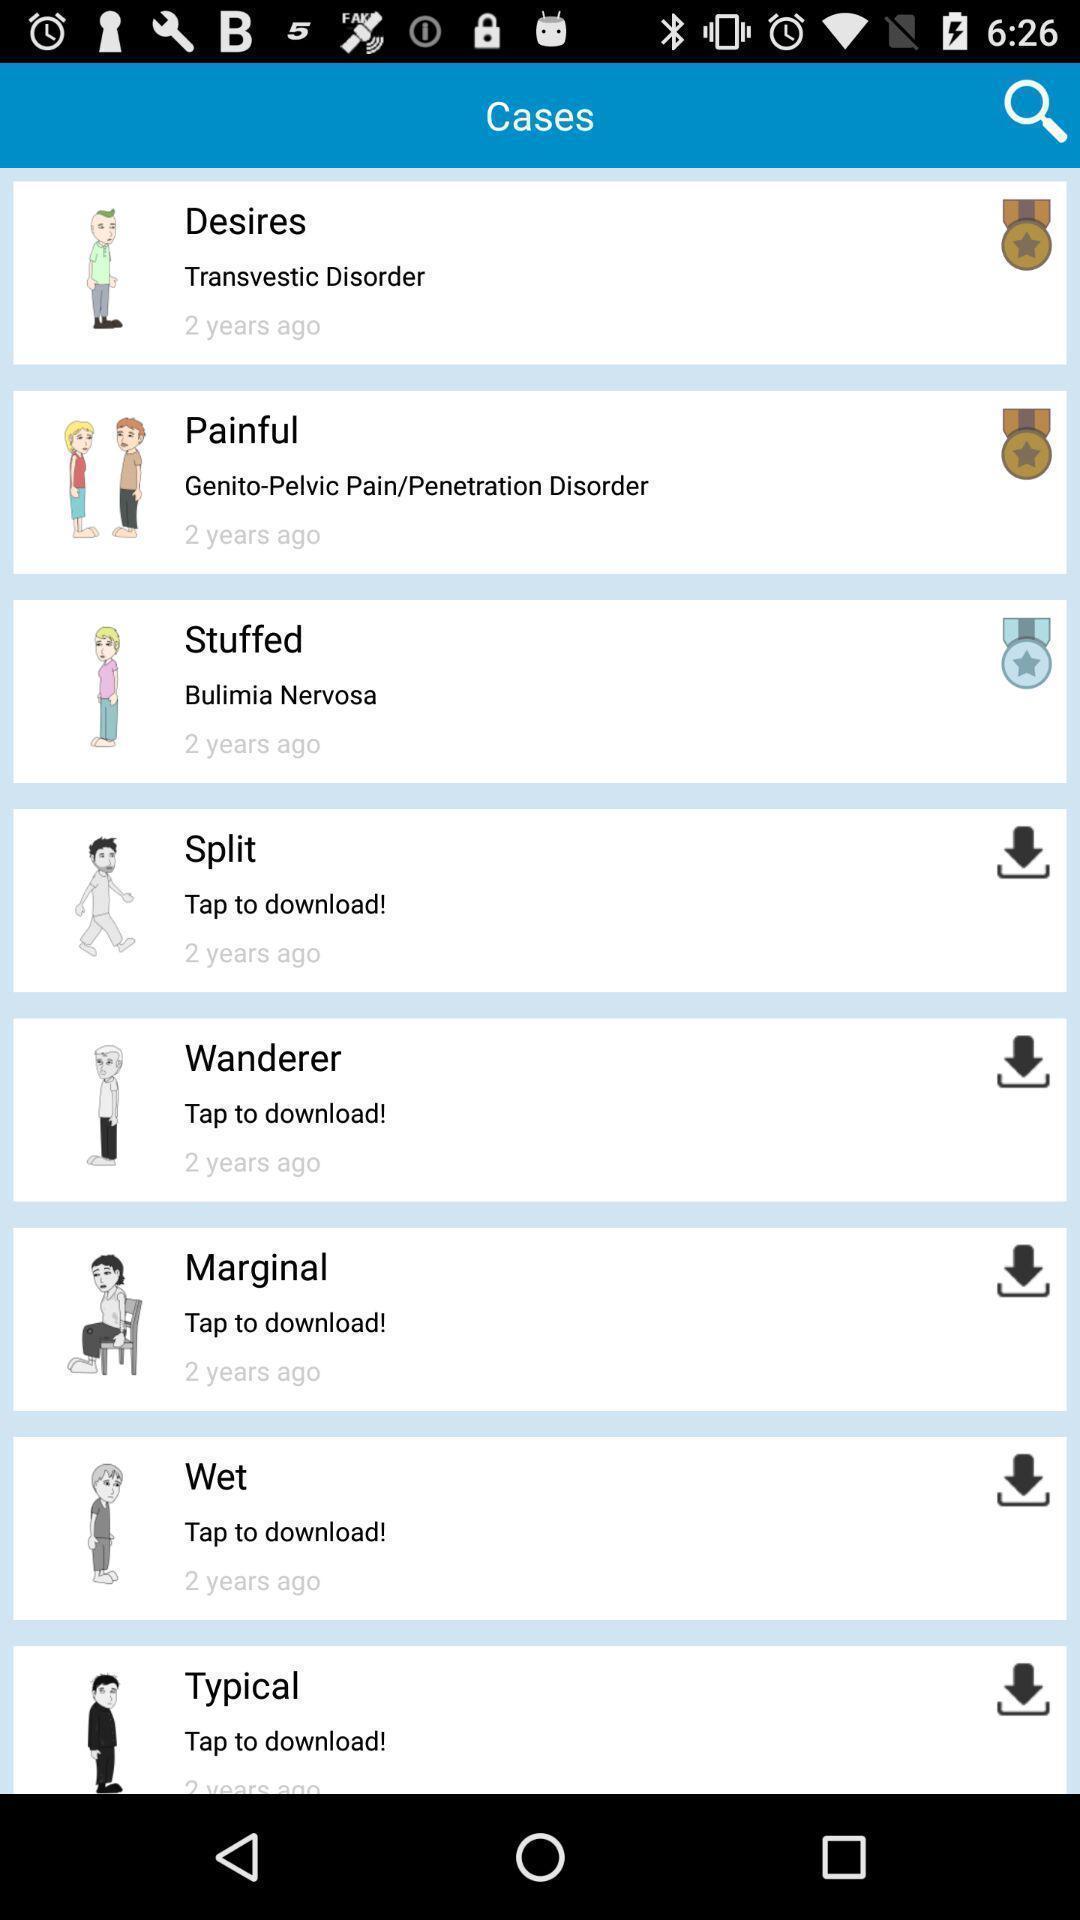Please provide a description for this image. Page showing the list of options to download. 